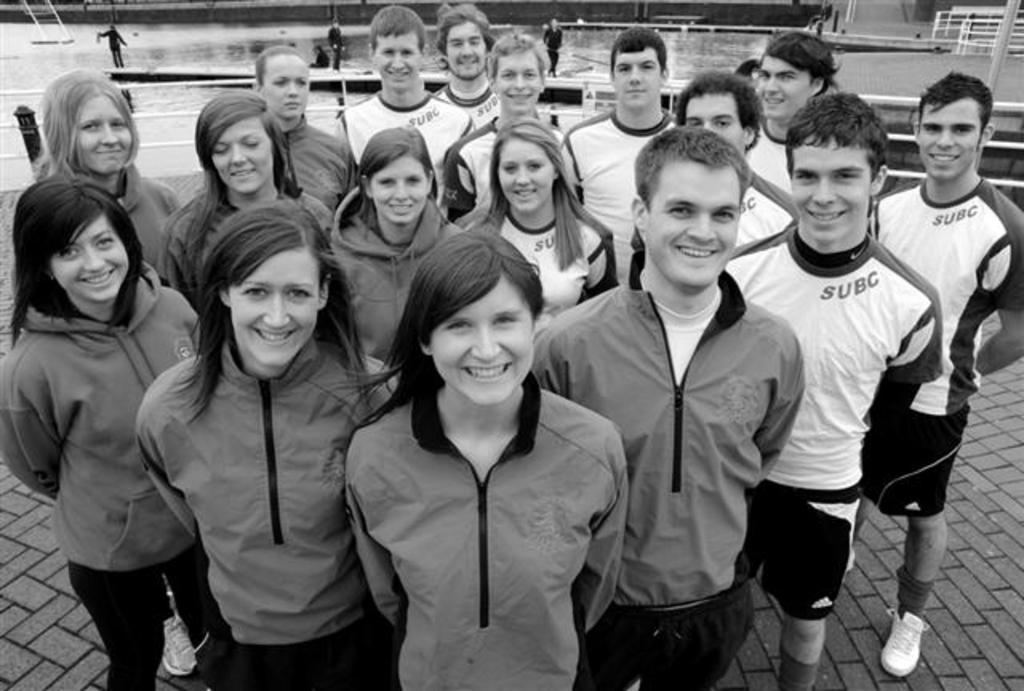How many people are in the group that is visible in the image? There is a group of people in the image, but the exact number is not specified. What are the people in the group doing? The people in the group are standing on the ground and smiling. Can you describe the background of the image? In the background of the image, there are other people, rods, water, and other objects visible. What is the general mood or expression of the people in the group? The people in the group are smiling, which suggests a positive or happy mood. How many rabbits can be seen digging a hole in the image? There are no rabbits or holes present in the image. What type of iron is being used by the people in the image? There is no iron visible in the image; the people are simply standing and smiling. 